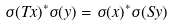<formula> <loc_0><loc_0><loc_500><loc_500>\sigma ( T x ) ^ { * } \sigma ( y ) = \sigma ( x ) ^ { * } \sigma ( S y )</formula> 